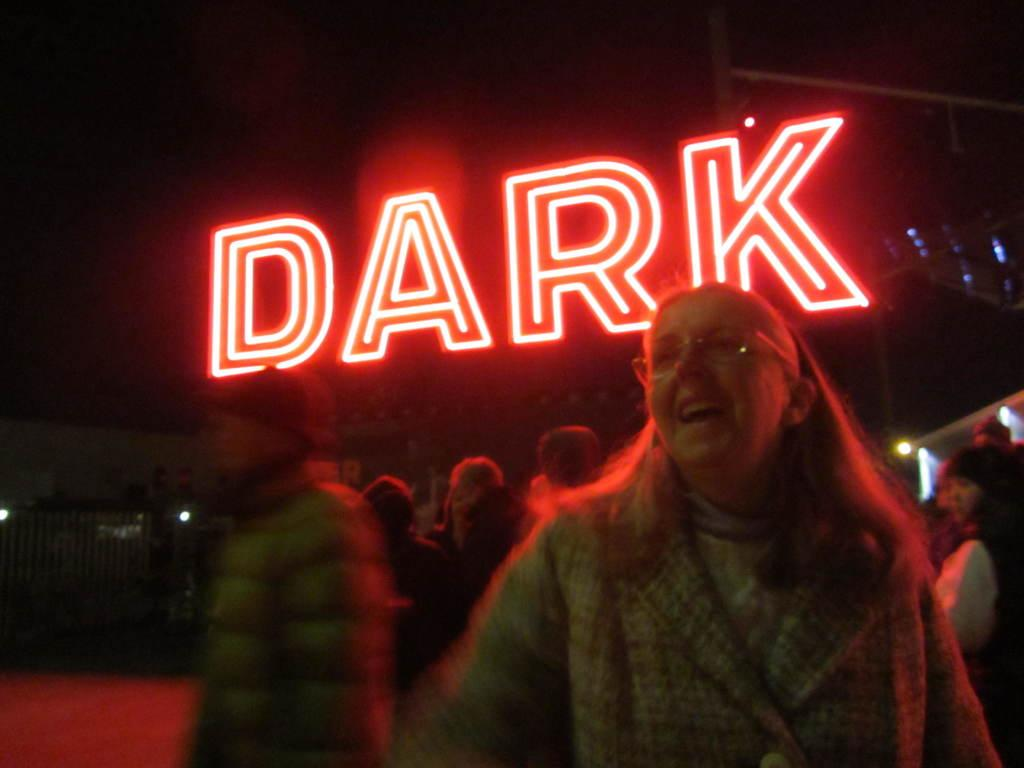What is located in the foreground of the image? There is a group of persons in the foreground of the image. What can be seen in the background of the image? There are lights, text, and other objects visible in the background of the image. Can you tell me how many records are visible on the ground in the image? There is no mention of records or a ground in the image; it only describes a group of persons in the foreground and lights, text, and other objects in the background. 